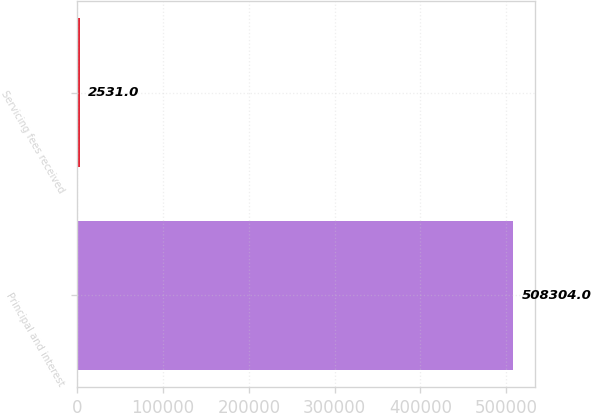Convert chart. <chart><loc_0><loc_0><loc_500><loc_500><bar_chart><fcel>Principal and interest<fcel>Servicing fees received<nl><fcel>508304<fcel>2531<nl></chart> 